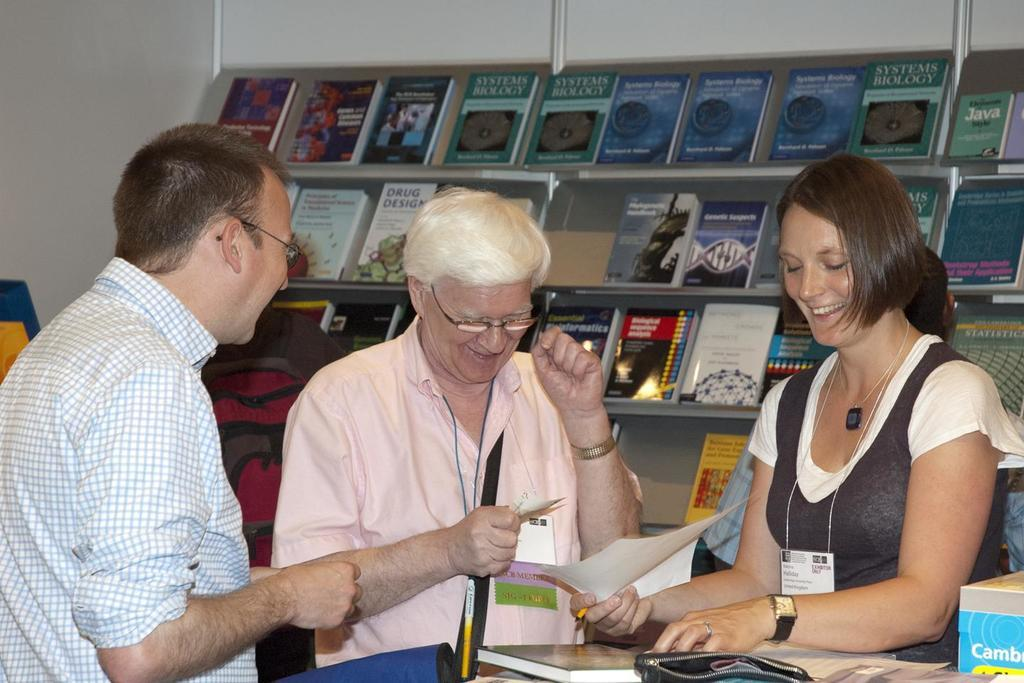How many people are in the image? There are two women and one man in the image. What are the individuals doing in the image? They are standing in the front and smiling. What are they looking at? They are looking at papers. What can be seen in the background of the image? There is a rack full of books and a white wall in the background. What is the name of the person standing on the left side of the image? The provided facts do not include any names of the individuals in the image. Can you see any cobwebs in the image? There is no mention of cobwebs in the provided facts, and they are not visible in the image. 